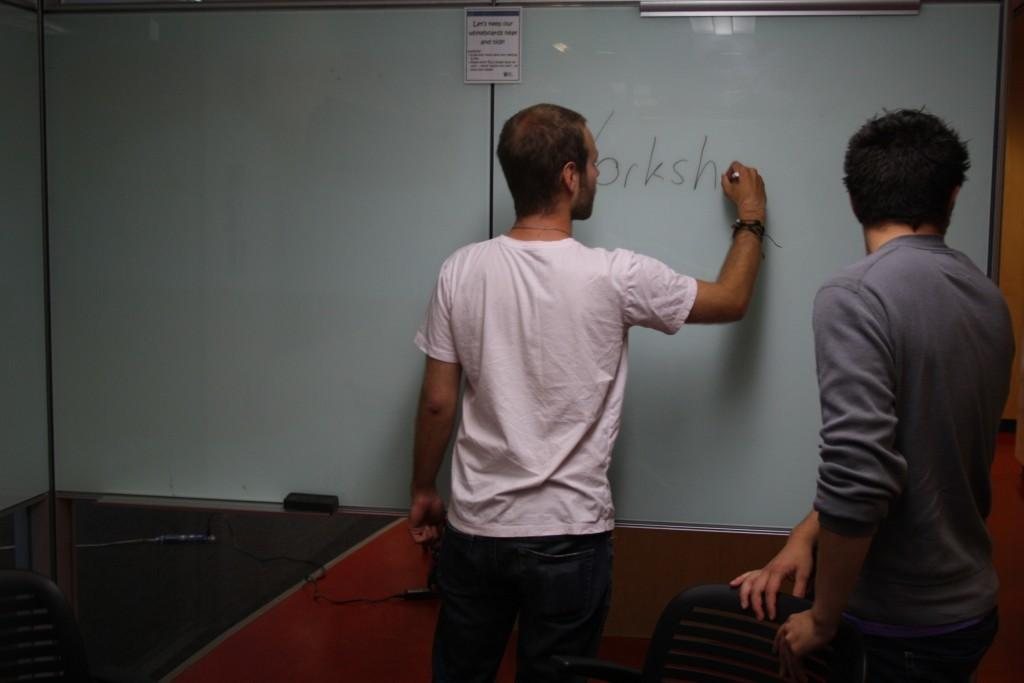<image>
Summarize the visual content of the image. A man writes the letters o r k s h on a white board while standing with another man. 